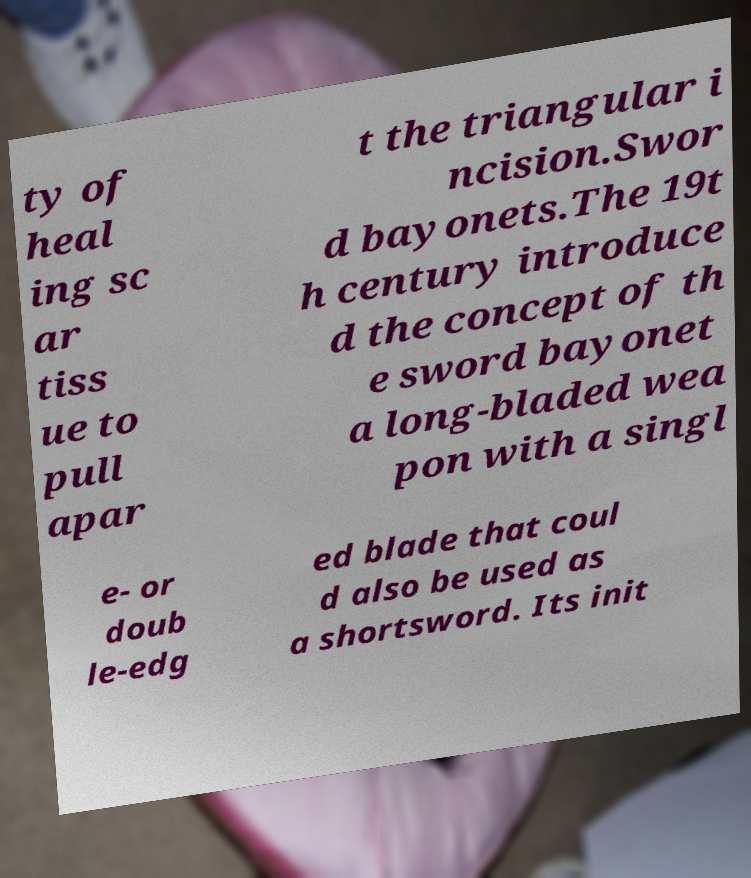Can you read and provide the text displayed in the image?This photo seems to have some interesting text. Can you extract and type it out for me? ty of heal ing sc ar tiss ue to pull apar t the triangular i ncision.Swor d bayonets.The 19t h century introduce d the concept of th e sword bayonet a long-bladed wea pon with a singl e- or doub le-edg ed blade that coul d also be used as a shortsword. Its init 